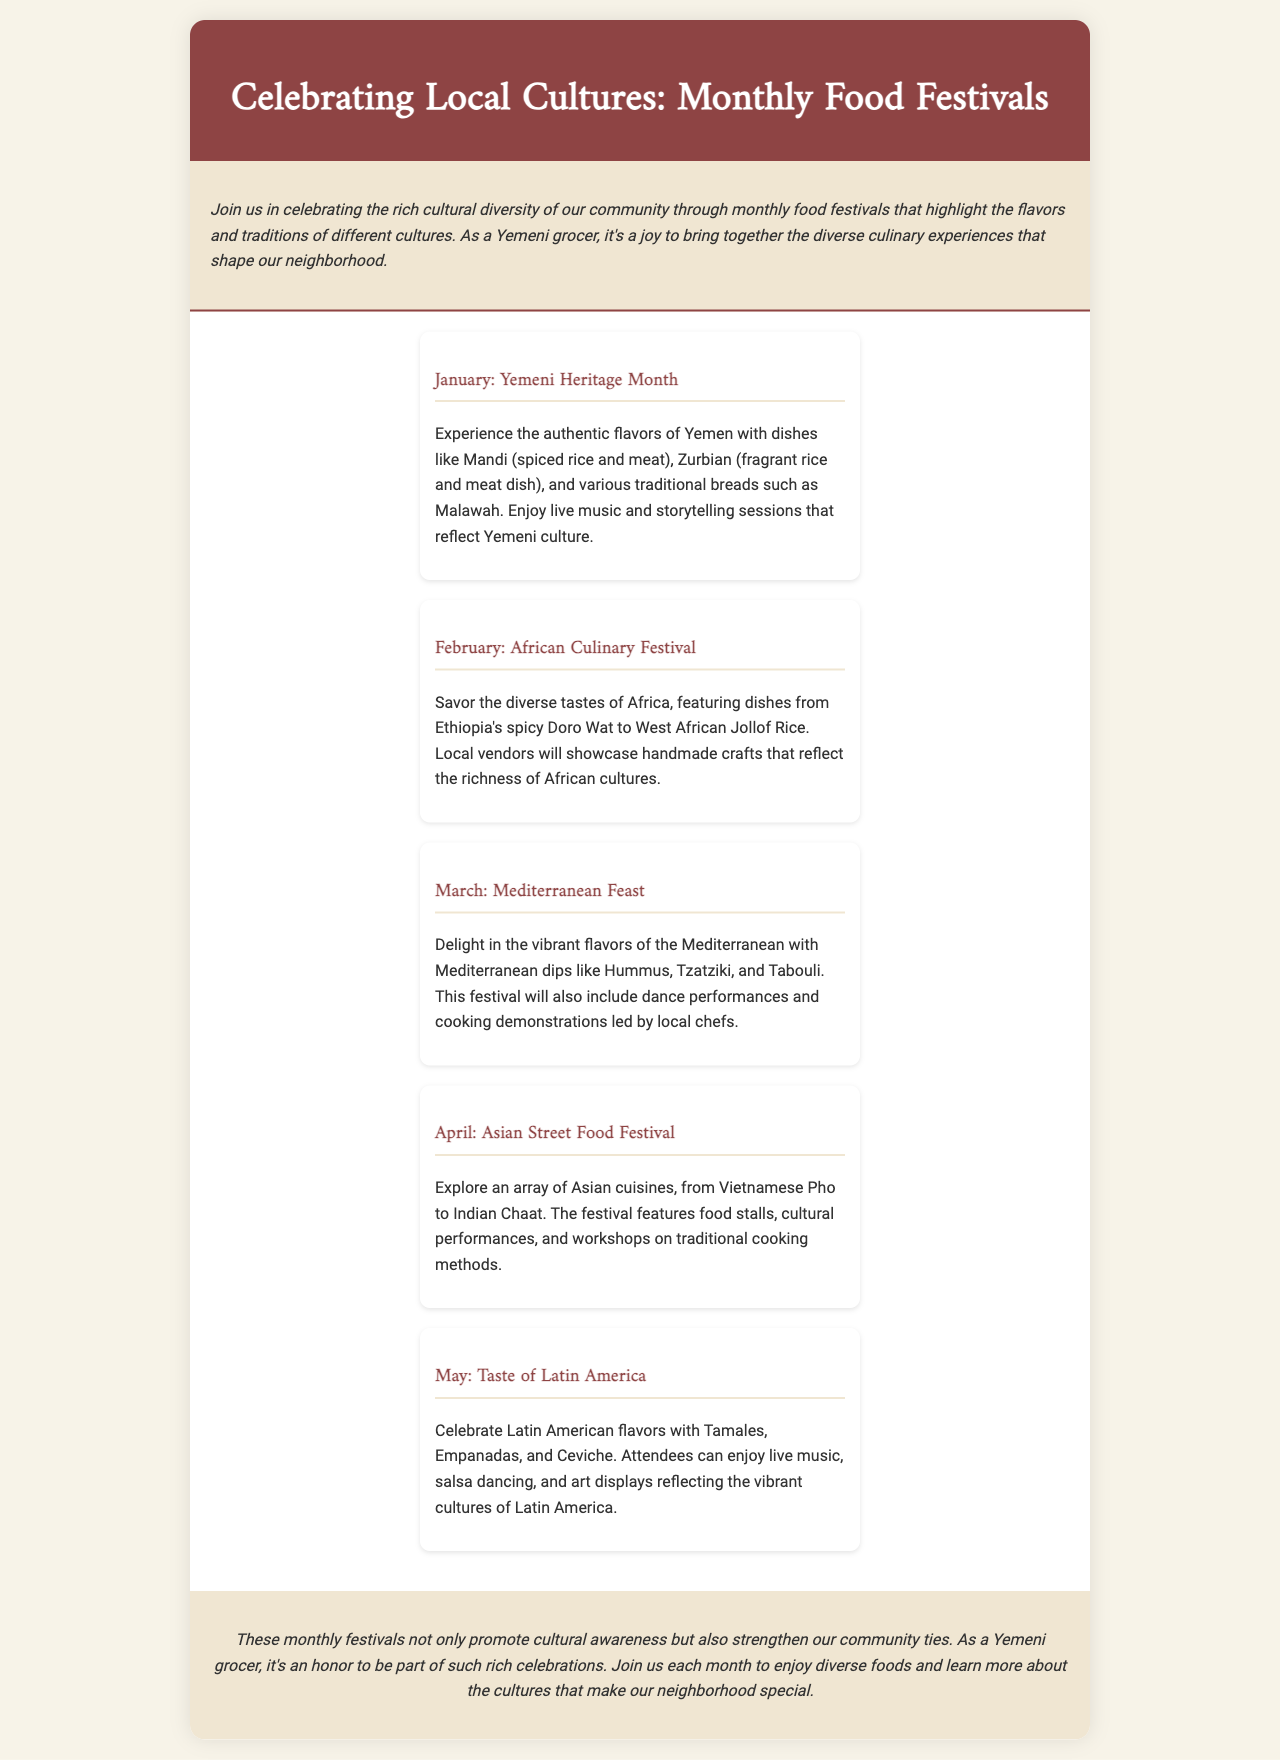what is the title of the brochure? The title is prominently displayed at the top of the document, introducing the theme of the content.
Answer: Celebrating Local Cultures: Monthly Food Festivals how many food festivals are described in the brochure? The brochure lists a total of five food festivals, each happening in a different month.
Answer: 5 what is featured in the January festival? The content describes specific dishes and activities that are part of the January festival highlighting Yemeni culture.
Answer: Mandi, Zurbian, traditional breads, live music, storytelling which month celebrates Latin American food? The festival dedicated to Latin American culinary offerings is mentioned in a specific month as per the document.
Answer: May what type of performances are included in the Mediterranean Feast? The document lists various activities associated with the Mediterranean festival, including cultural displays.
Answer: Dance performances, cooking demonstrations what is the purpose of these monthly food festivals? The main intent of organizing the festivals is described in the conclusion section, focusing on community and cultural connections.
Answer: Promote cultural awareness, strengthen community ties what activity does the Asian Street Food Festival include? The brochure outlines specific activities that characterize the Asian Street Food Festival, enhancing the cultural experience.
Answer: Food stalls, cultural performances, workshops what is emphasized about the neighborhood's food culture? The introduction expresses the key aspect of the neighborhood's food culture as a mix of different traditions and flavors.
Answer: Rich cultural diversity 